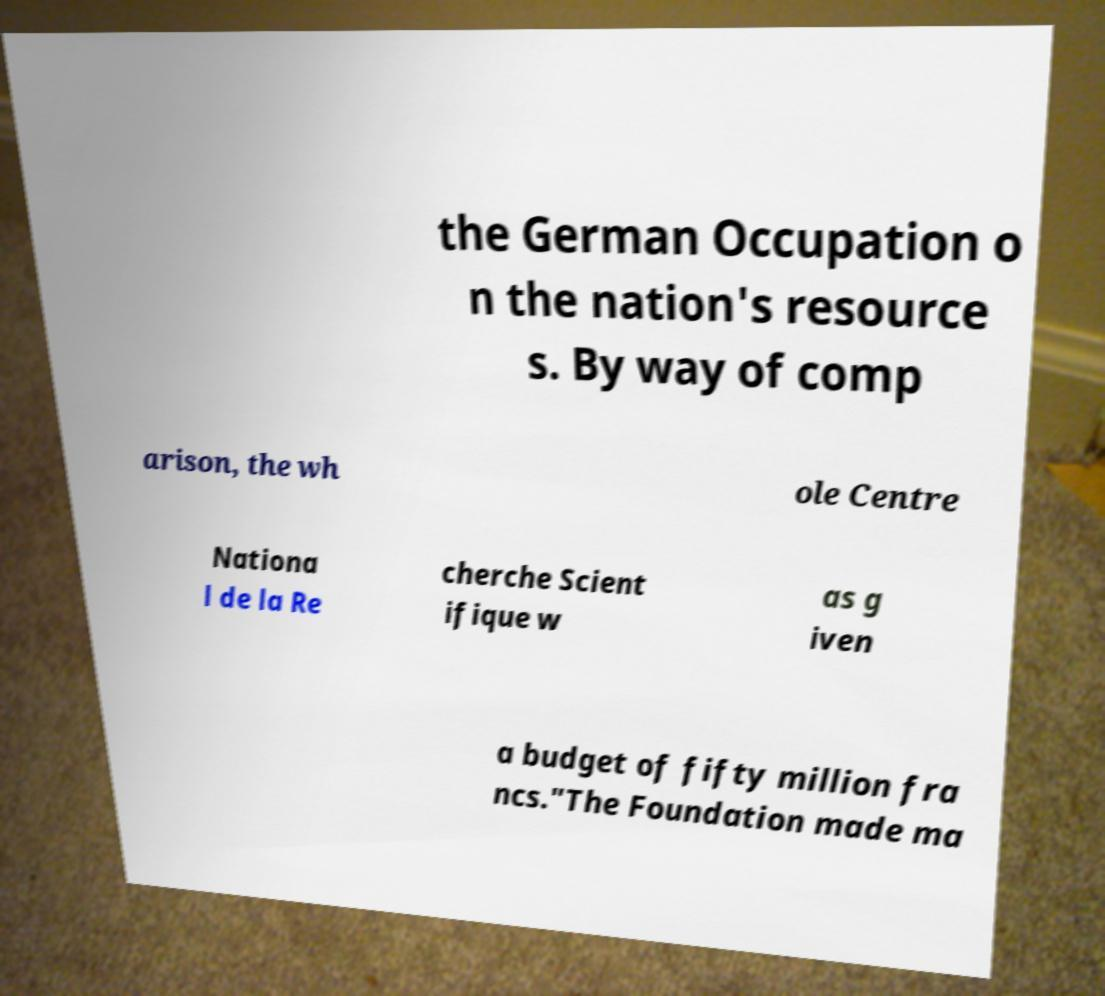There's text embedded in this image that I need extracted. Can you transcribe it verbatim? the German Occupation o n the nation's resource s. By way of comp arison, the wh ole Centre Nationa l de la Re cherche Scient ifique w as g iven a budget of fifty million fra ncs."The Foundation made ma 